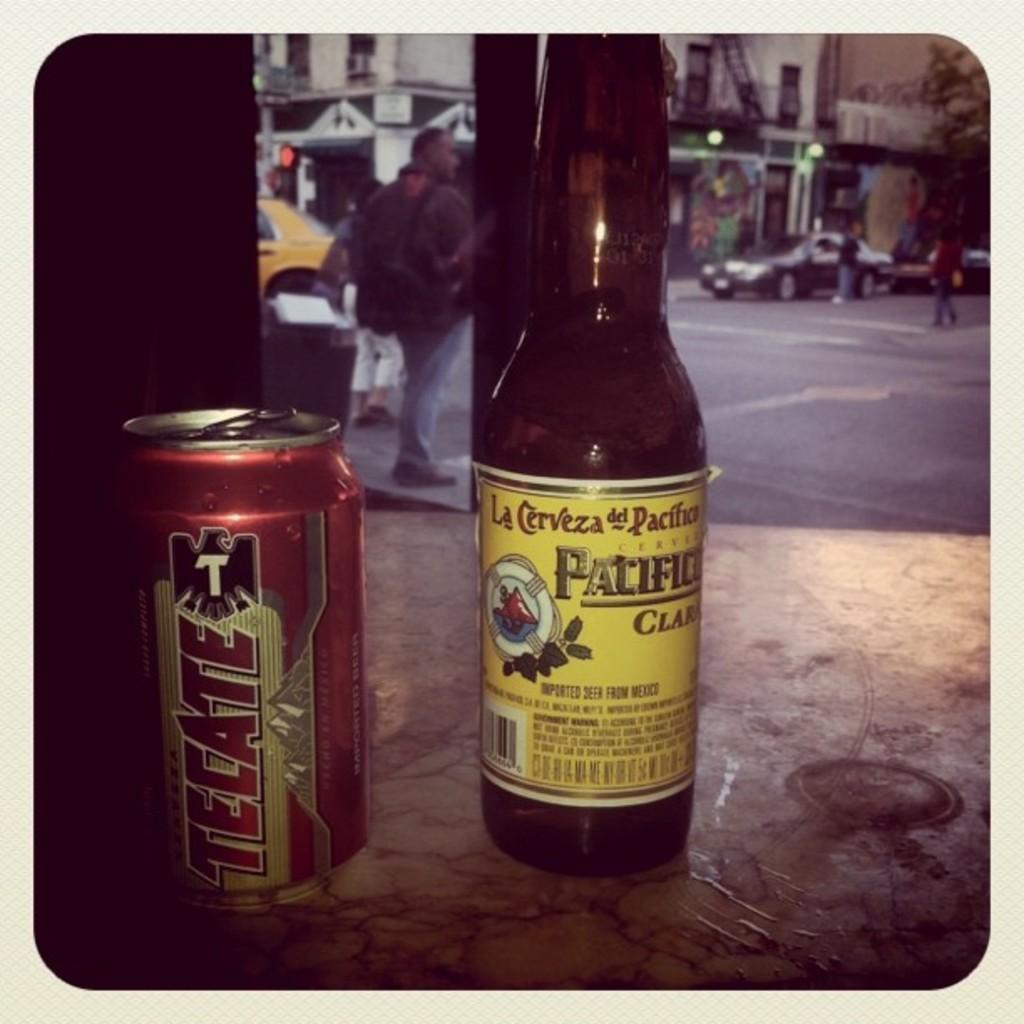<image>
Write a terse but informative summary of the picture. A can of Tecate beer on a table next to a bottle of imported beer from Mexico 